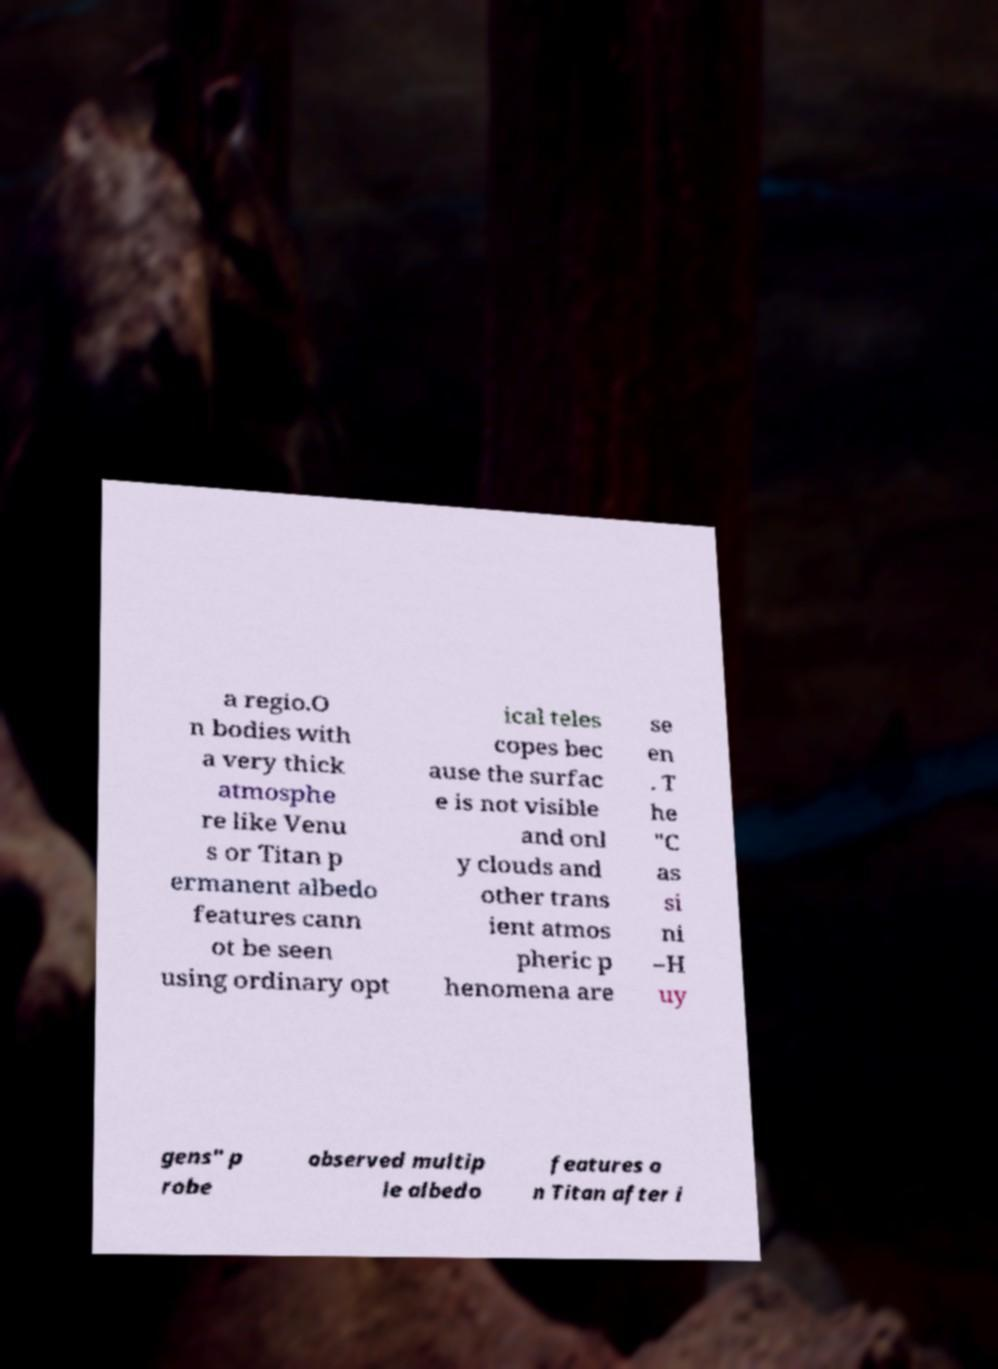Please read and relay the text visible in this image. What does it say? a regio.O n bodies with a very thick atmosphe re like Venu s or Titan p ermanent albedo features cann ot be seen using ordinary opt ical teles copes bec ause the surfac e is not visible and onl y clouds and other trans ient atmos pheric p henomena are se en . T he "C as si ni –H uy gens" p robe observed multip le albedo features o n Titan after i 